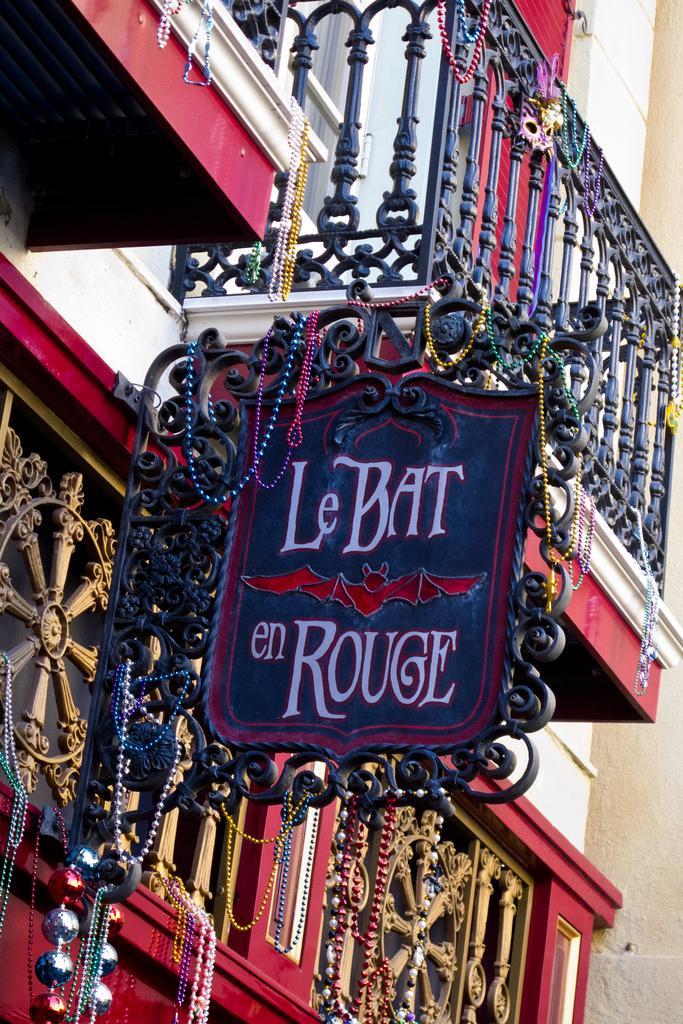Can you describe this image briefly? In this image I see a building and I see a board over here on which there are words and a bat picture over here and I see there are many colorful lockets. 